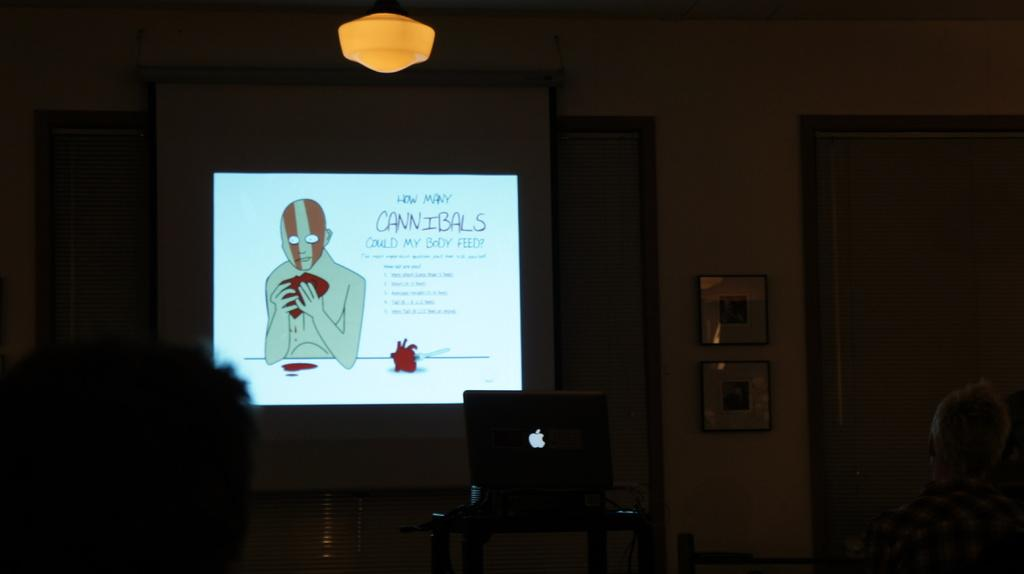How many people are in the image? There is a group of people in the image, but the exact number cannot be determined from the provided facts. What object is in front of the group? There is a laptop and a projector screen in front of the group. What type of lighting is present in the image? There is a light in front of the group. What can be seen on the wall in the image? There are frames on the wall in the image. Can you see any wounds on the people in the image? There is no mention of any wounds or injuries in the image, so we cannot answer that question. How many houses are visible in the image? There is no mention of any houses in the image, so we cannot answer that question. 